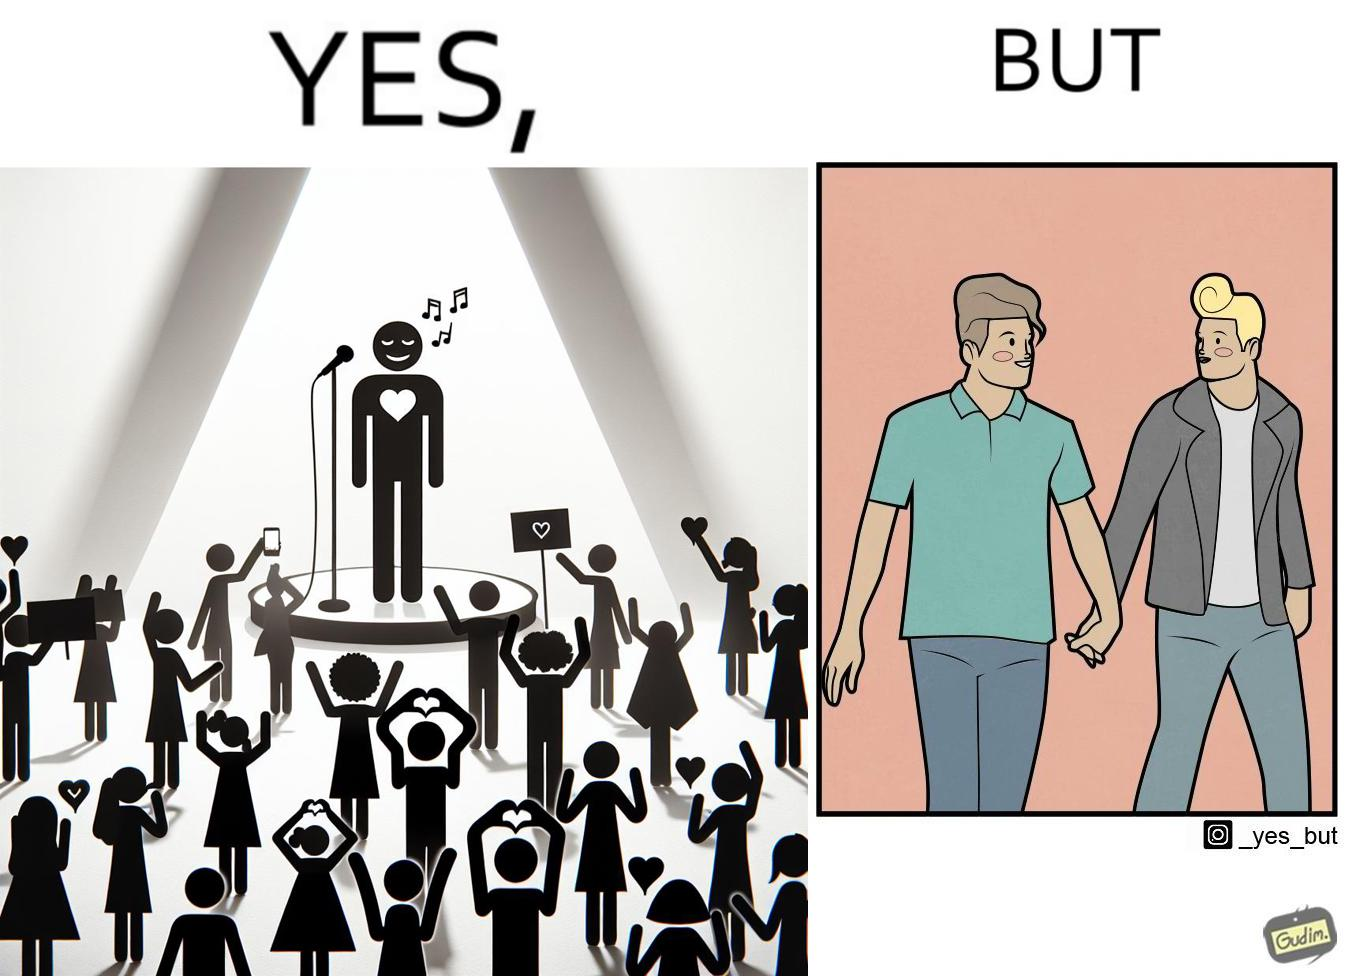Why is this image considered satirical? The image is funny because while the girls loves the man, he likes other men instead of women. 